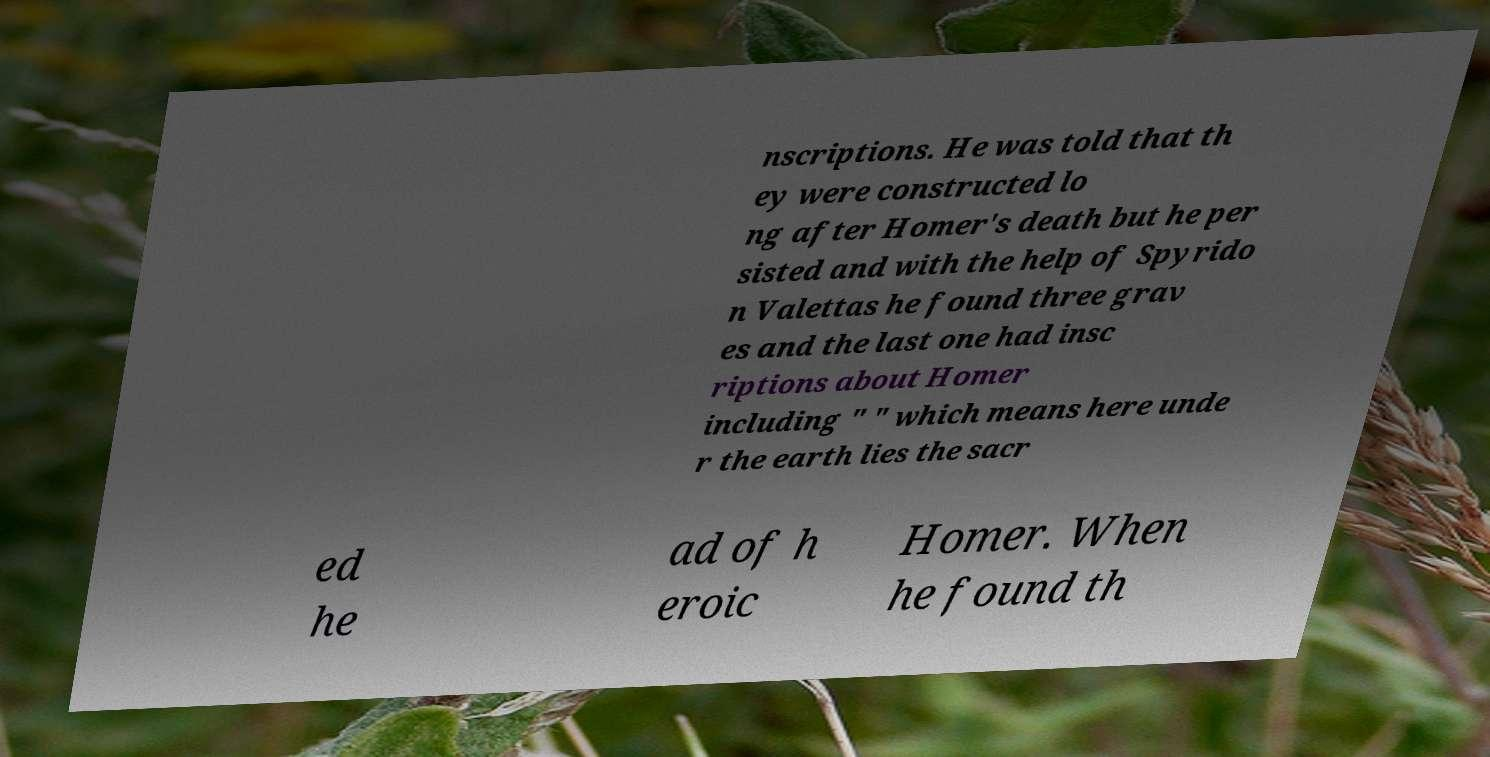Can you read and provide the text displayed in the image?This photo seems to have some interesting text. Can you extract and type it out for me? nscriptions. He was told that th ey were constructed lo ng after Homer's death but he per sisted and with the help of Spyrido n Valettas he found three grav es and the last one had insc riptions about Homer including " " which means here unde r the earth lies the sacr ed he ad of h eroic Homer. When he found th 